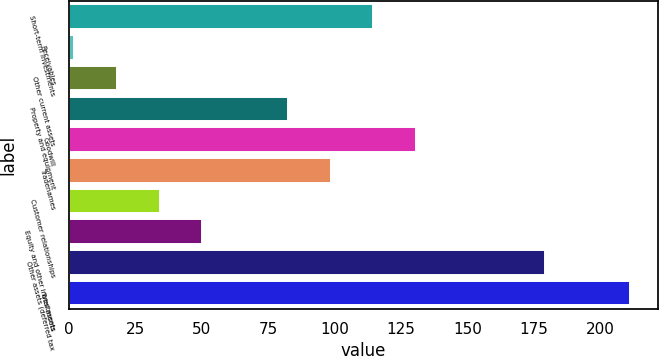Convert chart. <chart><loc_0><loc_0><loc_500><loc_500><bar_chart><fcel>Short-term investments<fcel>Receivables<fcel>Other current assets<fcel>Property and equipment<fcel>Goodwill<fcel>Tradenames<fcel>Customer relationships<fcel>Equity and other investments<fcel>Other assets (deferred tax<fcel>Total assets<nl><fcel>114.7<fcel>2<fcel>18.1<fcel>82.5<fcel>130.8<fcel>98.6<fcel>34.2<fcel>50.3<fcel>179.1<fcel>211.3<nl></chart> 